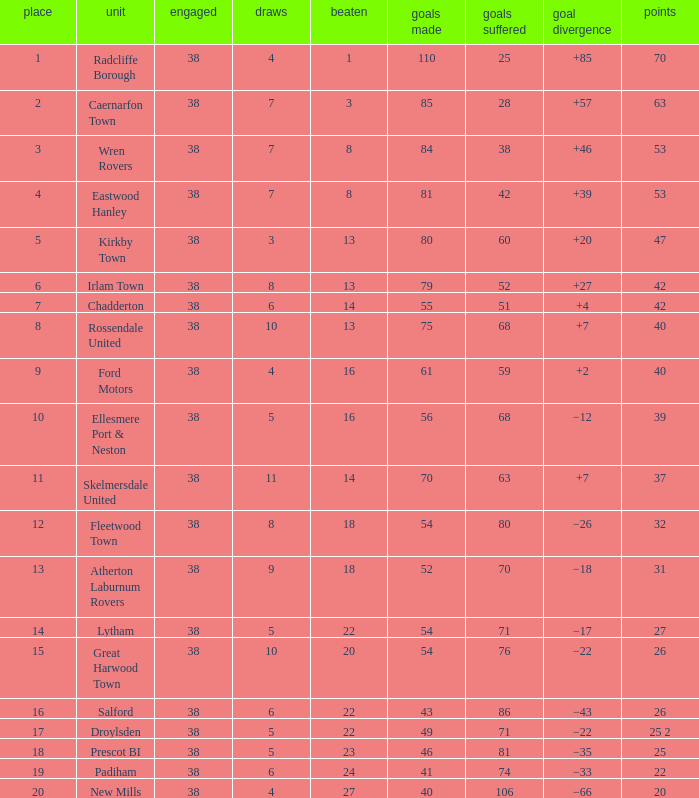Which Position has Goals For of 52, and Goals Against larger than 70? None. 